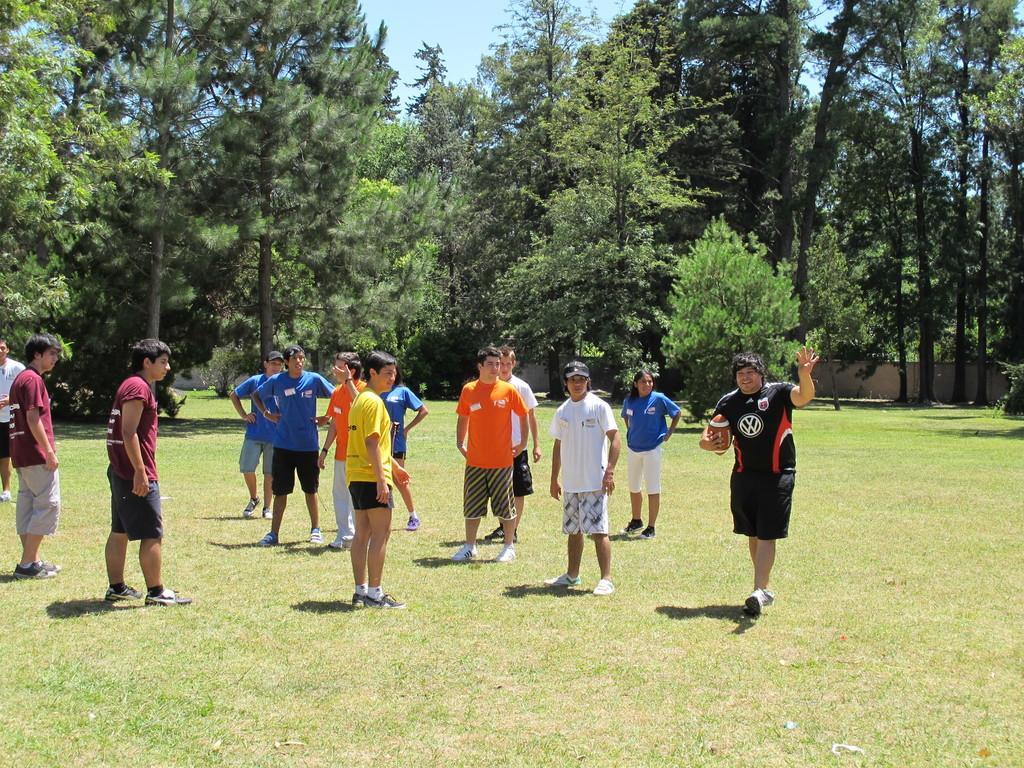In one or two sentences, can you explain what this image depicts? As we can see in the image there are few people here and there, grass and trees. On the top there is sky. 